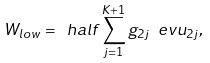<formula> <loc_0><loc_0><loc_500><loc_500>W _ { l o w } = \ h a l f \sum _ { j = 1 } ^ { K + 1 } g _ { 2 j } \ e v { u _ { 2 j } } ,</formula> 